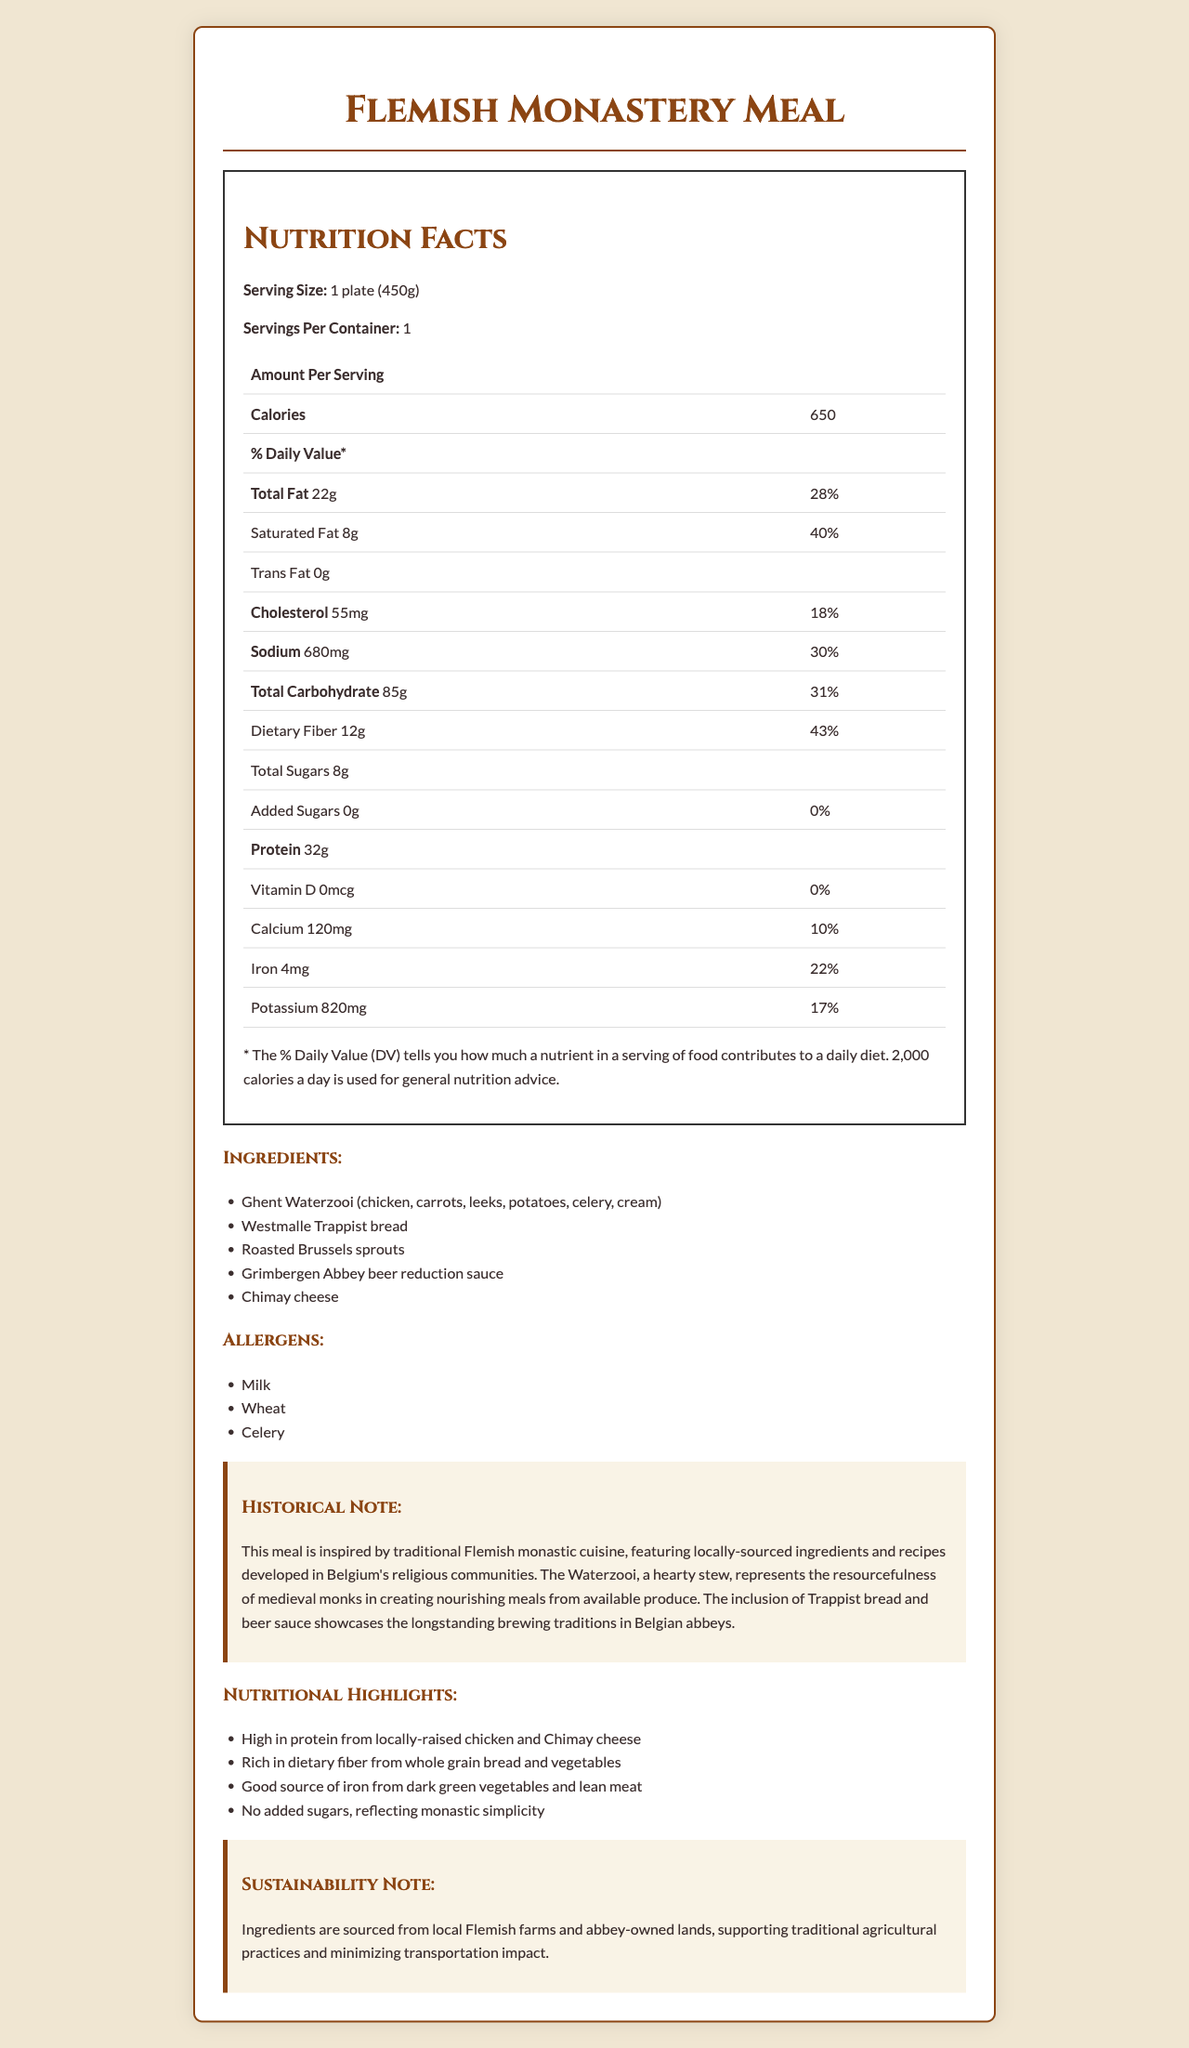what is the serving size? The serving size is specified as "1 plate (450g)" at the top of the Nutrition Facts section.
Answer: 1 plate (450g) How many calories are in one serving of the Flemish Monastery Meal? The document states that one serving contains 650 calories.
Answer: 650 What percentage of the daily value of saturated fat does the meal provide? According to the Nutrition Facts, the saturated fat content is 8g, which is 40% of the daily value.
Answer: 40% What is the source of the high dietary fiber content in the meal? The nutritional highlights mention that the meal is rich in dietary fiber from whole grain bread and vegetables.
Answer: Whole grain bread and vegetables Which allergen listed is not typically associated with dairy products? A. Milk B. Wheat C. Celery The allergens listed include milk, wheat, and celery. Celery is not typically associated with dairy products.
Answer: C. Celery Which key ingredient is used in the sauce? It is listed under the ingredients as part of the meal.
Answer: Grimbergen Abbey beer reduction Does this meal have any added sugars? The document specifies that there are 0g added sugars in the meal.
Answer: No What aspect of the meal reflects monastic simplicity? The nutritional highlights mention that there are no added sugars, reflecting monastic simplicity.
Answer: No added sugars What traditional Belgian beverage is included in the meal's ingredients? A. Westmalle Trappist beer B. Grimbergen Abbey beer C. Chimay Ale The ingredient listed under the sauce is Grimbergen Abbey beer reduction.
Answer: B. Grimbergen Abbey beer How much protein is in one serving of the meal? The Nutrition Facts state that there are 32g of protein per serving.
Answer: 32g Is this meal gluten-free? Wheat is listed as an allergen, indicating that the meal contains gluten.
Answer: No Summarize the main idea of this document. The document details the nutritional content and historical background of a Flemish Monastery Meal, emphasizing its health benefits and local, sustainable sourcing.
Answer: The document provides a nutrition facts label for a meal inspired by traditional Flemish monastic cuisine, featuring local ingredients like Ghent Waterzooi, Westmalle Trappist bread, and Chimay cheese. It highlights various nutritional benefits, including high protein and dietary fiber, and notes the historical and sustainability aspects of the ingredients. What is the daily value percentage of iron provided by this meal? The Nutrition Facts show that the meal provides 4mg of iron, which is 22% of the daily value.
Answer: 22% Are there any sustainability practices mentioned about the ingredients? The sustainability note mentions that ingredients are sourced from local Flemish farms and abbey-owned lands, supporting traditional agricultural practices and minimizing transportation impact.
Answer: Yes What is the specific type of bread used in this meal? The ingredient list includes Westmalle Trappist bread.
Answer: Westmalle Trappist bread Where can I find the recipe for this meal? The document does not provide a recipe or any details on where to find it.
Answer: Not enough information How many grams of dietary fiber are in the meal? According to the Nutrition Facts, the meal contains 12g of dietary fiber.
Answer: 12g Which ingredient listed reflects the brewing traditions in Belgian abbeys? The historical note mentions the inclusion of beer sauce showcasing the brewing traditions, specifically Grimbergen Abbey beer.
Answer: Grimbergen Abbey beer 